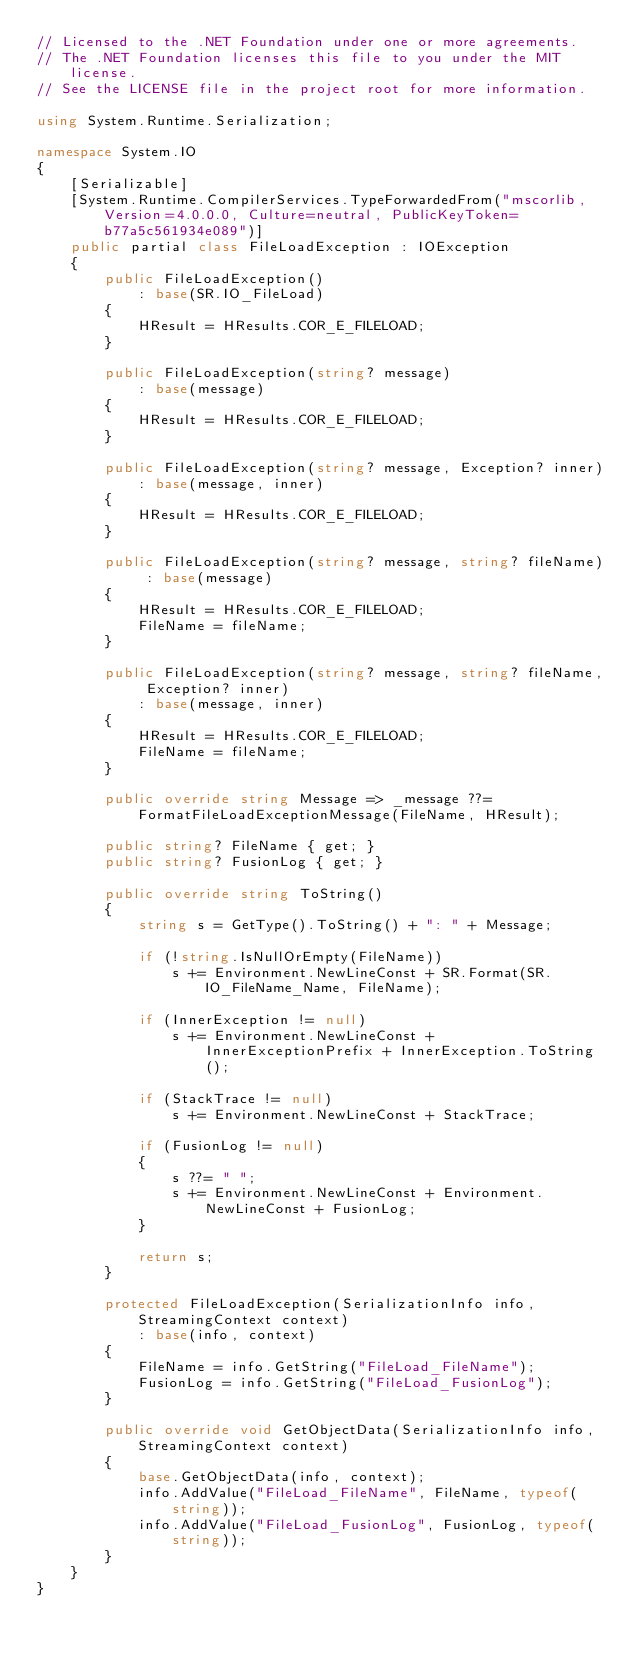<code> <loc_0><loc_0><loc_500><loc_500><_C#_>// Licensed to the .NET Foundation under one or more agreements.
// The .NET Foundation licenses this file to you under the MIT license.
// See the LICENSE file in the project root for more information.

using System.Runtime.Serialization;

namespace System.IO
{
    [Serializable]
    [System.Runtime.CompilerServices.TypeForwardedFrom("mscorlib, Version=4.0.0.0, Culture=neutral, PublicKeyToken=b77a5c561934e089")]
    public partial class FileLoadException : IOException
    {
        public FileLoadException()
            : base(SR.IO_FileLoad)
        {
            HResult = HResults.COR_E_FILELOAD;
        }

        public FileLoadException(string? message)
            : base(message)
        {
            HResult = HResults.COR_E_FILELOAD;
        }

        public FileLoadException(string? message, Exception? inner)
            : base(message, inner)
        {
            HResult = HResults.COR_E_FILELOAD;
        }

        public FileLoadException(string? message, string? fileName) : base(message)
        {
            HResult = HResults.COR_E_FILELOAD;
            FileName = fileName;
        }

        public FileLoadException(string? message, string? fileName, Exception? inner)
            : base(message, inner)
        {
            HResult = HResults.COR_E_FILELOAD;
            FileName = fileName;
        }

        public override string Message => _message ??= FormatFileLoadExceptionMessage(FileName, HResult);

        public string? FileName { get; }
        public string? FusionLog { get; }

        public override string ToString()
        {
            string s = GetType().ToString() + ": " + Message;

            if (!string.IsNullOrEmpty(FileName))
                s += Environment.NewLineConst + SR.Format(SR.IO_FileName_Name, FileName);

            if (InnerException != null)
                s += Environment.NewLineConst + InnerExceptionPrefix + InnerException.ToString();

            if (StackTrace != null)
                s += Environment.NewLineConst + StackTrace;

            if (FusionLog != null)
            {
                s ??= " ";
                s += Environment.NewLineConst + Environment.NewLineConst + FusionLog;
            }

            return s;
        }

        protected FileLoadException(SerializationInfo info, StreamingContext context)
            : base(info, context)
        {
            FileName = info.GetString("FileLoad_FileName");
            FusionLog = info.GetString("FileLoad_FusionLog");
        }

        public override void GetObjectData(SerializationInfo info, StreamingContext context)
        {
            base.GetObjectData(info, context);
            info.AddValue("FileLoad_FileName", FileName, typeof(string));
            info.AddValue("FileLoad_FusionLog", FusionLog, typeof(string));
        }
    }
}
</code> 